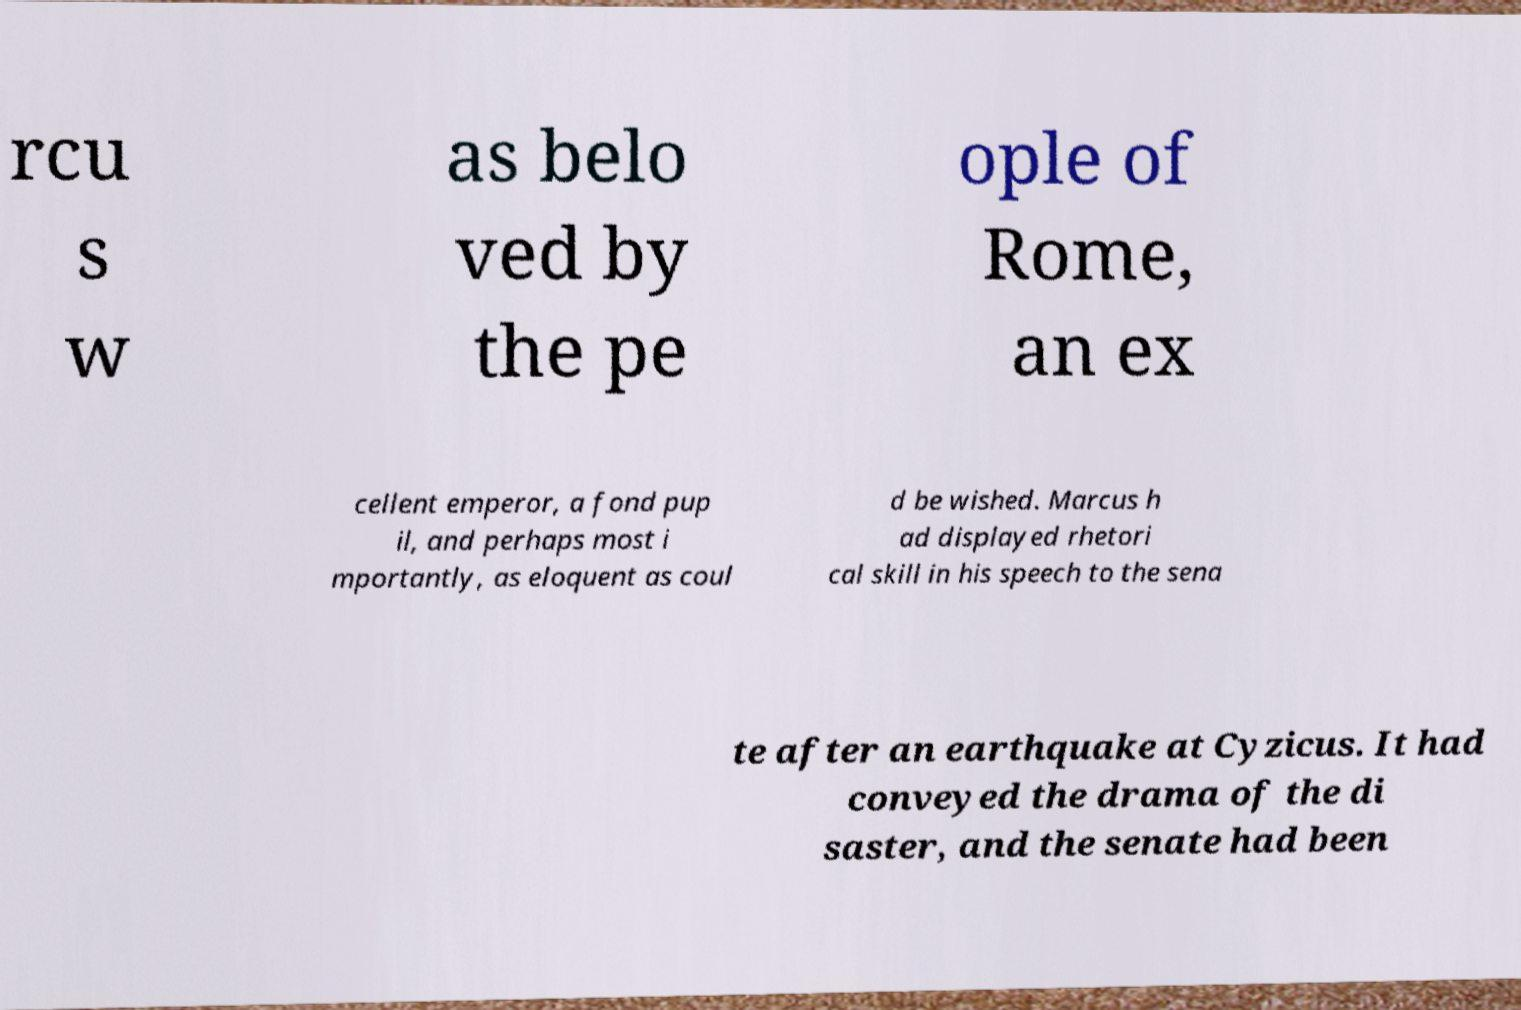Can you read and provide the text displayed in the image?This photo seems to have some interesting text. Can you extract and type it out for me? rcu s w as belo ved by the pe ople of Rome, an ex cellent emperor, a fond pup il, and perhaps most i mportantly, as eloquent as coul d be wished. Marcus h ad displayed rhetori cal skill in his speech to the sena te after an earthquake at Cyzicus. It had conveyed the drama of the di saster, and the senate had been 